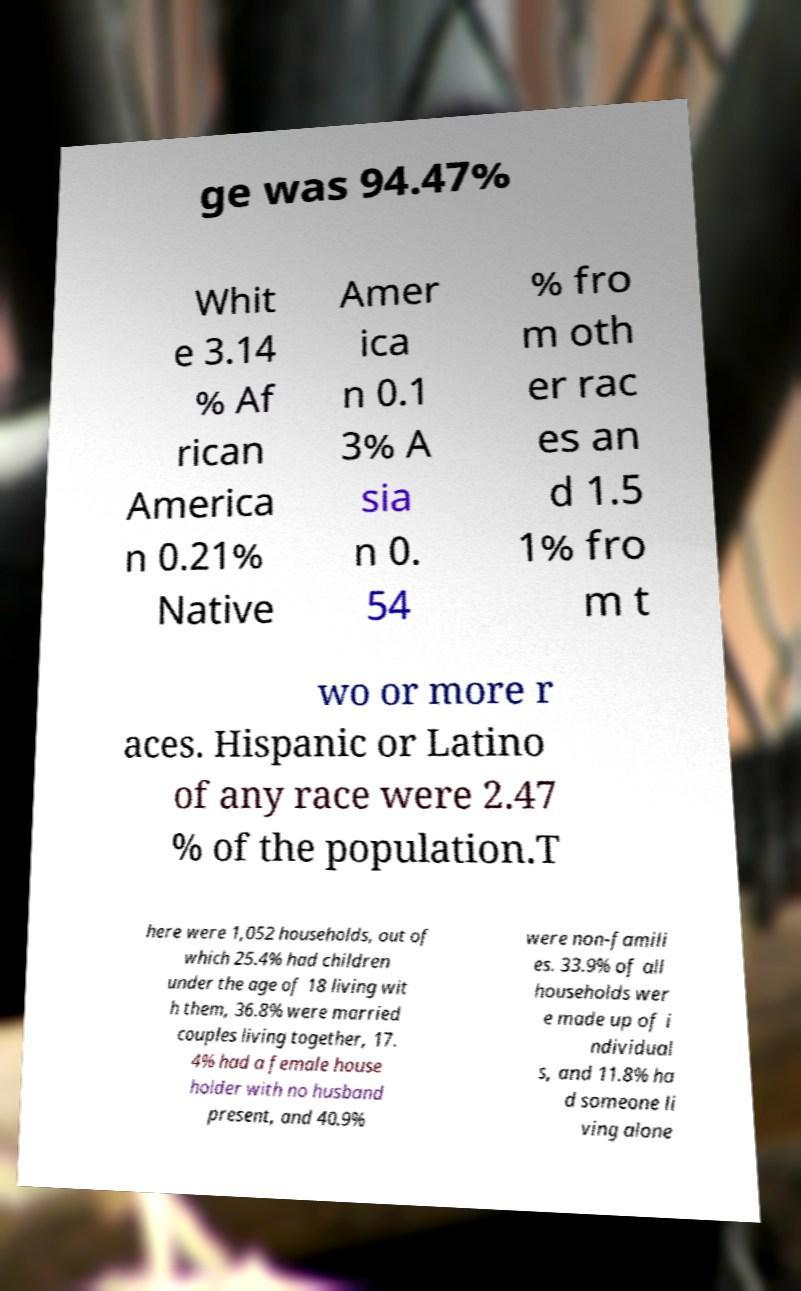Can you accurately transcribe the text from the provided image for me? ge was 94.47% Whit e 3.14 % Af rican America n 0.21% Native Amer ica n 0.1 3% A sia n 0. 54 % fro m oth er rac es an d 1.5 1% fro m t wo or more r aces. Hispanic or Latino of any race were 2.47 % of the population.T here were 1,052 households, out of which 25.4% had children under the age of 18 living wit h them, 36.8% were married couples living together, 17. 4% had a female house holder with no husband present, and 40.9% were non-famili es. 33.9% of all households wer e made up of i ndividual s, and 11.8% ha d someone li ving alone 